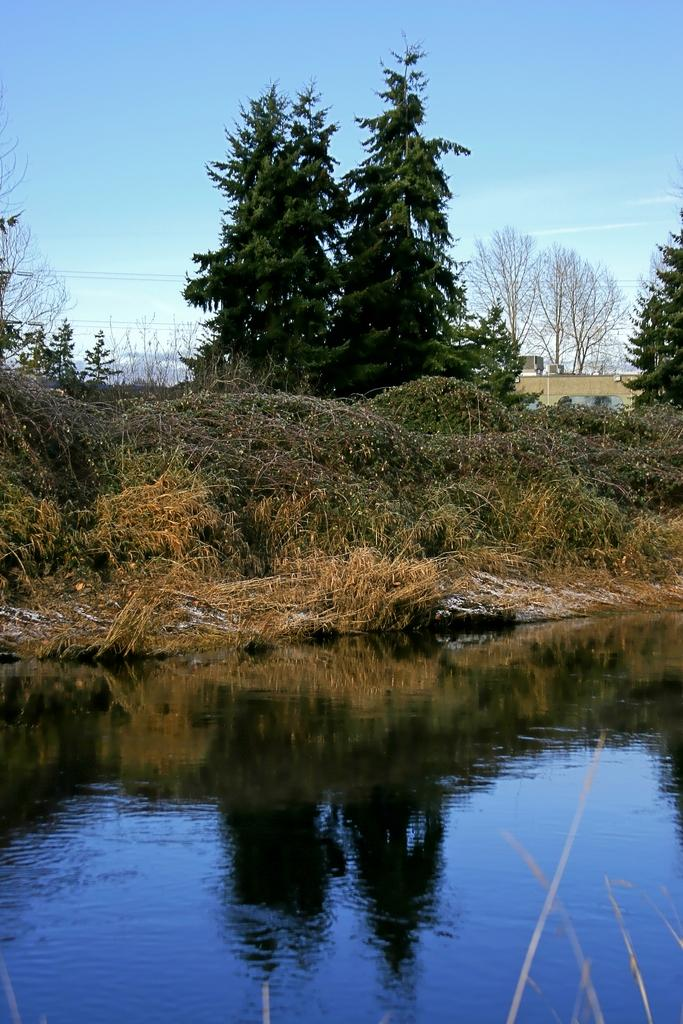What is present at the bottom of the image? There is water at the bottom of the image. What can be seen in the center of the image? There are trees in the center of the image. What is visible in the background of the image? The sky is visible in the background of the image, along with wires. What type of force can be seen pushing the trees in the image? There is no force pushing the trees in the image; they are standing still. Is this image taken in a park? The provided facts do not mention a park, so we cannot determine if the image was taken in a park or not. 